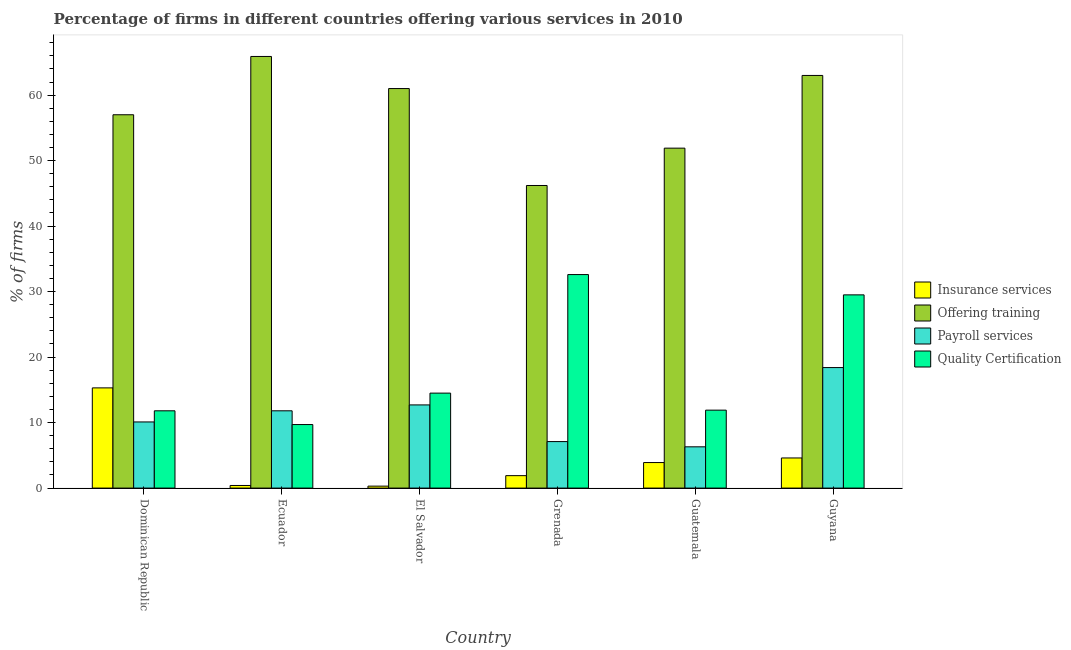How many groups of bars are there?
Provide a succinct answer. 6. How many bars are there on the 6th tick from the right?
Your answer should be compact. 4. What is the label of the 3rd group of bars from the left?
Your answer should be compact. El Salvador. In how many cases, is the number of bars for a given country not equal to the number of legend labels?
Provide a short and direct response. 0. Across all countries, what is the minimum percentage of firms offering insurance services?
Your answer should be very brief. 0.3. In which country was the percentage of firms offering training maximum?
Give a very brief answer. Ecuador. In which country was the percentage of firms offering insurance services minimum?
Your response must be concise. El Salvador. What is the total percentage of firms offering training in the graph?
Provide a succinct answer. 345. What is the difference between the percentage of firms offering payroll services in El Salvador and that in Guyana?
Offer a very short reply. -5.7. What is the difference between the percentage of firms offering insurance services in Ecuador and the percentage of firms offering training in Dominican Republic?
Provide a succinct answer. -56.6. What is the average percentage of firms offering quality certification per country?
Provide a short and direct response. 18.33. In how many countries, is the percentage of firms offering insurance services greater than 60 %?
Offer a terse response. 0. What is the ratio of the percentage of firms offering quality certification in Ecuador to that in Grenada?
Provide a succinct answer. 0.3. What is the difference between the highest and the second highest percentage of firms offering training?
Make the answer very short. 2.9. What is the difference between the highest and the lowest percentage of firms offering payroll services?
Provide a succinct answer. 12.1. In how many countries, is the percentage of firms offering training greater than the average percentage of firms offering training taken over all countries?
Make the answer very short. 3. Is the sum of the percentage of firms offering training in El Salvador and Grenada greater than the maximum percentage of firms offering insurance services across all countries?
Offer a very short reply. Yes. Is it the case that in every country, the sum of the percentage of firms offering payroll services and percentage of firms offering training is greater than the sum of percentage of firms offering insurance services and percentage of firms offering quality certification?
Provide a short and direct response. Yes. What does the 2nd bar from the left in Grenada represents?
Offer a terse response. Offering training. What does the 3rd bar from the right in Grenada represents?
Offer a very short reply. Offering training. Is it the case that in every country, the sum of the percentage of firms offering insurance services and percentage of firms offering training is greater than the percentage of firms offering payroll services?
Make the answer very short. Yes. How many bars are there?
Offer a terse response. 24. Are all the bars in the graph horizontal?
Keep it short and to the point. No. How many countries are there in the graph?
Your answer should be compact. 6. Are the values on the major ticks of Y-axis written in scientific E-notation?
Your answer should be very brief. No. Where does the legend appear in the graph?
Offer a very short reply. Center right. How many legend labels are there?
Your response must be concise. 4. How are the legend labels stacked?
Ensure brevity in your answer.  Vertical. What is the title of the graph?
Make the answer very short. Percentage of firms in different countries offering various services in 2010. What is the label or title of the Y-axis?
Offer a terse response. % of firms. What is the % of firms of Insurance services in Dominican Republic?
Give a very brief answer. 15.3. What is the % of firms in Offering training in Dominican Republic?
Make the answer very short. 57. What is the % of firms in Payroll services in Dominican Republic?
Offer a terse response. 10.1. What is the % of firms in Offering training in Ecuador?
Give a very brief answer. 65.9. What is the % of firms in Quality Certification in Ecuador?
Your answer should be compact. 9.7. What is the % of firms of Offering training in El Salvador?
Provide a succinct answer. 61. What is the % of firms of Payroll services in El Salvador?
Make the answer very short. 12.7. What is the % of firms of Quality Certification in El Salvador?
Ensure brevity in your answer.  14.5. What is the % of firms of Offering training in Grenada?
Keep it short and to the point. 46.2. What is the % of firms in Payroll services in Grenada?
Make the answer very short. 7.1. What is the % of firms of Quality Certification in Grenada?
Provide a succinct answer. 32.6. What is the % of firms of Offering training in Guatemala?
Your answer should be compact. 51.9. What is the % of firms of Quality Certification in Guatemala?
Ensure brevity in your answer.  11.9. What is the % of firms of Quality Certification in Guyana?
Offer a terse response. 29.5. Across all countries, what is the maximum % of firms of Offering training?
Provide a short and direct response. 65.9. Across all countries, what is the maximum % of firms of Quality Certification?
Your response must be concise. 32.6. Across all countries, what is the minimum % of firms in Offering training?
Offer a terse response. 46.2. What is the total % of firms of Insurance services in the graph?
Keep it short and to the point. 26.4. What is the total % of firms in Offering training in the graph?
Provide a succinct answer. 345. What is the total % of firms of Payroll services in the graph?
Offer a very short reply. 66.4. What is the total % of firms in Quality Certification in the graph?
Make the answer very short. 110. What is the difference between the % of firms of Quality Certification in Dominican Republic and that in Grenada?
Your response must be concise. -20.8. What is the difference between the % of firms of Payroll services in Dominican Republic and that in Guatemala?
Keep it short and to the point. 3.8. What is the difference between the % of firms in Quality Certification in Dominican Republic and that in Guyana?
Give a very brief answer. -17.7. What is the difference between the % of firms of Insurance services in Ecuador and that in El Salvador?
Ensure brevity in your answer.  0.1. What is the difference between the % of firms of Payroll services in Ecuador and that in El Salvador?
Offer a very short reply. -0.9. What is the difference between the % of firms in Payroll services in Ecuador and that in Grenada?
Make the answer very short. 4.7. What is the difference between the % of firms of Quality Certification in Ecuador and that in Grenada?
Offer a very short reply. -22.9. What is the difference between the % of firms of Insurance services in Ecuador and that in Guatemala?
Your answer should be compact. -3.5. What is the difference between the % of firms of Offering training in Ecuador and that in Guyana?
Give a very brief answer. 2.9. What is the difference between the % of firms of Quality Certification in Ecuador and that in Guyana?
Keep it short and to the point. -19.8. What is the difference between the % of firms in Offering training in El Salvador and that in Grenada?
Offer a terse response. 14.8. What is the difference between the % of firms in Quality Certification in El Salvador and that in Grenada?
Offer a terse response. -18.1. What is the difference between the % of firms of Payroll services in El Salvador and that in Guatemala?
Make the answer very short. 6.4. What is the difference between the % of firms of Payroll services in El Salvador and that in Guyana?
Offer a terse response. -5.7. What is the difference between the % of firms of Insurance services in Grenada and that in Guatemala?
Ensure brevity in your answer.  -2. What is the difference between the % of firms of Quality Certification in Grenada and that in Guatemala?
Ensure brevity in your answer.  20.7. What is the difference between the % of firms in Offering training in Grenada and that in Guyana?
Offer a very short reply. -16.8. What is the difference between the % of firms in Payroll services in Grenada and that in Guyana?
Provide a short and direct response. -11.3. What is the difference between the % of firms in Insurance services in Guatemala and that in Guyana?
Offer a very short reply. -0.7. What is the difference between the % of firms in Offering training in Guatemala and that in Guyana?
Offer a terse response. -11.1. What is the difference between the % of firms in Payroll services in Guatemala and that in Guyana?
Make the answer very short. -12.1. What is the difference between the % of firms in Quality Certification in Guatemala and that in Guyana?
Your answer should be compact. -17.6. What is the difference between the % of firms in Insurance services in Dominican Republic and the % of firms in Offering training in Ecuador?
Your answer should be compact. -50.6. What is the difference between the % of firms of Insurance services in Dominican Republic and the % of firms of Quality Certification in Ecuador?
Provide a succinct answer. 5.6. What is the difference between the % of firms of Offering training in Dominican Republic and the % of firms of Payroll services in Ecuador?
Give a very brief answer. 45.2. What is the difference between the % of firms in Offering training in Dominican Republic and the % of firms in Quality Certification in Ecuador?
Offer a very short reply. 47.3. What is the difference between the % of firms in Payroll services in Dominican Republic and the % of firms in Quality Certification in Ecuador?
Provide a succinct answer. 0.4. What is the difference between the % of firms in Insurance services in Dominican Republic and the % of firms in Offering training in El Salvador?
Your answer should be very brief. -45.7. What is the difference between the % of firms in Insurance services in Dominican Republic and the % of firms in Quality Certification in El Salvador?
Your response must be concise. 0.8. What is the difference between the % of firms in Offering training in Dominican Republic and the % of firms in Payroll services in El Salvador?
Your answer should be compact. 44.3. What is the difference between the % of firms of Offering training in Dominican Republic and the % of firms of Quality Certification in El Salvador?
Provide a short and direct response. 42.5. What is the difference between the % of firms in Insurance services in Dominican Republic and the % of firms in Offering training in Grenada?
Offer a very short reply. -30.9. What is the difference between the % of firms in Insurance services in Dominican Republic and the % of firms in Quality Certification in Grenada?
Your answer should be very brief. -17.3. What is the difference between the % of firms in Offering training in Dominican Republic and the % of firms in Payroll services in Grenada?
Provide a succinct answer. 49.9. What is the difference between the % of firms in Offering training in Dominican Republic and the % of firms in Quality Certification in Grenada?
Make the answer very short. 24.4. What is the difference between the % of firms of Payroll services in Dominican Republic and the % of firms of Quality Certification in Grenada?
Offer a very short reply. -22.5. What is the difference between the % of firms in Insurance services in Dominican Republic and the % of firms in Offering training in Guatemala?
Offer a very short reply. -36.6. What is the difference between the % of firms in Insurance services in Dominican Republic and the % of firms in Payroll services in Guatemala?
Keep it short and to the point. 9. What is the difference between the % of firms of Insurance services in Dominican Republic and the % of firms of Quality Certification in Guatemala?
Give a very brief answer. 3.4. What is the difference between the % of firms of Offering training in Dominican Republic and the % of firms of Payroll services in Guatemala?
Your response must be concise. 50.7. What is the difference between the % of firms of Offering training in Dominican Republic and the % of firms of Quality Certification in Guatemala?
Give a very brief answer. 45.1. What is the difference between the % of firms of Insurance services in Dominican Republic and the % of firms of Offering training in Guyana?
Your response must be concise. -47.7. What is the difference between the % of firms in Insurance services in Dominican Republic and the % of firms in Quality Certification in Guyana?
Your answer should be very brief. -14.2. What is the difference between the % of firms in Offering training in Dominican Republic and the % of firms in Payroll services in Guyana?
Provide a short and direct response. 38.6. What is the difference between the % of firms of Payroll services in Dominican Republic and the % of firms of Quality Certification in Guyana?
Your answer should be very brief. -19.4. What is the difference between the % of firms of Insurance services in Ecuador and the % of firms of Offering training in El Salvador?
Your answer should be compact. -60.6. What is the difference between the % of firms in Insurance services in Ecuador and the % of firms in Payroll services in El Salvador?
Offer a terse response. -12.3. What is the difference between the % of firms in Insurance services in Ecuador and the % of firms in Quality Certification in El Salvador?
Offer a very short reply. -14.1. What is the difference between the % of firms of Offering training in Ecuador and the % of firms of Payroll services in El Salvador?
Offer a terse response. 53.2. What is the difference between the % of firms in Offering training in Ecuador and the % of firms in Quality Certification in El Salvador?
Provide a succinct answer. 51.4. What is the difference between the % of firms in Insurance services in Ecuador and the % of firms in Offering training in Grenada?
Give a very brief answer. -45.8. What is the difference between the % of firms of Insurance services in Ecuador and the % of firms of Quality Certification in Grenada?
Your answer should be compact. -32.2. What is the difference between the % of firms in Offering training in Ecuador and the % of firms in Payroll services in Grenada?
Provide a succinct answer. 58.8. What is the difference between the % of firms in Offering training in Ecuador and the % of firms in Quality Certification in Grenada?
Give a very brief answer. 33.3. What is the difference between the % of firms in Payroll services in Ecuador and the % of firms in Quality Certification in Grenada?
Provide a succinct answer. -20.8. What is the difference between the % of firms in Insurance services in Ecuador and the % of firms in Offering training in Guatemala?
Make the answer very short. -51.5. What is the difference between the % of firms of Offering training in Ecuador and the % of firms of Payroll services in Guatemala?
Ensure brevity in your answer.  59.6. What is the difference between the % of firms of Insurance services in Ecuador and the % of firms of Offering training in Guyana?
Your answer should be compact. -62.6. What is the difference between the % of firms of Insurance services in Ecuador and the % of firms of Payroll services in Guyana?
Your answer should be very brief. -18. What is the difference between the % of firms of Insurance services in Ecuador and the % of firms of Quality Certification in Guyana?
Ensure brevity in your answer.  -29.1. What is the difference between the % of firms of Offering training in Ecuador and the % of firms of Payroll services in Guyana?
Give a very brief answer. 47.5. What is the difference between the % of firms in Offering training in Ecuador and the % of firms in Quality Certification in Guyana?
Ensure brevity in your answer.  36.4. What is the difference between the % of firms of Payroll services in Ecuador and the % of firms of Quality Certification in Guyana?
Give a very brief answer. -17.7. What is the difference between the % of firms of Insurance services in El Salvador and the % of firms of Offering training in Grenada?
Your answer should be very brief. -45.9. What is the difference between the % of firms of Insurance services in El Salvador and the % of firms of Payroll services in Grenada?
Provide a succinct answer. -6.8. What is the difference between the % of firms of Insurance services in El Salvador and the % of firms of Quality Certification in Grenada?
Keep it short and to the point. -32.3. What is the difference between the % of firms of Offering training in El Salvador and the % of firms of Payroll services in Grenada?
Your answer should be very brief. 53.9. What is the difference between the % of firms of Offering training in El Salvador and the % of firms of Quality Certification in Grenada?
Offer a very short reply. 28.4. What is the difference between the % of firms in Payroll services in El Salvador and the % of firms in Quality Certification in Grenada?
Provide a short and direct response. -19.9. What is the difference between the % of firms of Insurance services in El Salvador and the % of firms of Offering training in Guatemala?
Your answer should be compact. -51.6. What is the difference between the % of firms in Insurance services in El Salvador and the % of firms in Payroll services in Guatemala?
Provide a succinct answer. -6. What is the difference between the % of firms in Insurance services in El Salvador and the % of firms in Quality Certification in Guatemala?
Give a very brief answer. -11.6. What is the difference between the % of firms of Offering training in El Salvador and the % of firms of Payroll services in Guatemala?
Your answer should be very brief. 54.7. What is the difference between the % of firms of Offering training in El Salvador and the % of firms of Quality Certification in Guatemala?
Your answer should be very brief. 49.1. What is the difference between the % of firms in Payroll services in El Salvador and the % of firms in Quality Certification in Guatemala?
Provide a succinct answer. 0.8. What is the difference between the % of firms of Insurance services in El Salvador and the % of firms of Offering training in Guyana?
Provide a succinct answer. -62.7. What is the difference between the % of firms of Insurance services in El Salvador and the % of firms of Payroll services in Guyana?
Your response must be concise. -18.1. What is the difference between the % of firms of Insurance services in El Salvador and the % of firms of Quality Certification in Guyana?
Your answer should be compact. -29.2. What is the difference between the % of firms of Offering training in El Salvador and the % of firms of Payroll services in Guyana?
Offer a very short reply. 42.6. What is the difference between the % of firms of Offering training in El Salvador and the % of firms of Quality Certification in Guyana?
Provide a short and direct response. 31.5. What is the difference between the % of firms of Payroll services in El Salvador and the % of firms of Quality Certification in Guyana?
Make the answer very short. -16.8. What is the difference between the % of firms in Insurance services in Grenada and the % of firms in Quality Certification in Guatemala?
Provide a succinct answer. -10. What is the difference between the % of firms of Offering training in Grenada and the % of firms of Payroll services in Guatemala?
Ensure brevity in your answer.  39.9. What is the difference between the % of firms of Offering training in Grenada and the % of firms of Quality Certification in Guatemala?
Offer a very short reply. 34.3. What is the difference between the % of firms in Payroll services in Grenada and the % of firms in Quality Certification in Guatemala?
Offer a very short reply. -4.8. What is the difference between the % of firms of Insurance services in Grenada and the % of firms of Offering training in Guyana?
Offer a very short reply. -61.1. What is the difference between the % of firms of Insurance services in Grenada and the % of firms of Payroll services in Guyana?
Provide a succinct answer. -16.5. What is the difference between the % of firms in Insurance services in Grenada and the % of firms in Quality Certification in Guyana?
Offer a terse response. -27.6. What is the difference between the % of firms of Offering training in Grenada and the % of firms of Payroll services in Guyana?
Offer a terse response. 27.8. What is the difference between the % of firms of Payroll services in Grenada and the % of firms of Quality Certification in Guyana?
Keep it short and to the point. -22.4. What is the difference between the % of firms in Insurance services in Guatemala and the % of firms in Offering training in Guyana?
Make the answer very short. -59.1. What is the difference between the % of firms in Insurance services in Guatemala and the % of firms in Payroll services in Guyana?
Keep it short and to the point. -14.5. What is the difference between the % of firms in Insurance services in Guatemala and the % of firms in Quality Certification in Guyana?
Your answer should be compact. -25.6. What is the difference between the % of firms in Offering training in Guatemala and the % of firms in Payroll services in Guyana?
Your answer should be very brief. 33.5. What is the difference between the % of firms of Offering training in Guatemala and the % of firms of Quality Certification in Guyana?
Keep it short and to the point. 22.4. What is the difference between the % of firms of Payroll services in Guatemala and the % of firms of Quality Certification in Guyana?
Offer a terse response. -23.2. What is the average % of firms of Offering training per country?
Make the answer very short. 57.5. What is the average % of firms of Payroll services per country?
Make the answer very short. 11.07. What is the average % of firms in Quality Certification per country?
Your answer should be compact. 18.33. What is the difference between the % of firms in Insurance services and % of firms in Offering training in Dominican Republic?
Offer a very short reply. -41.7. What is the difference between the % of firms in Insurance services and % of firms in Quality Certification in Dominican Republic?
Your response must be concise. 3.5. What is the difference between the % of firms of Offering training and % of firms of Payroll services in Dominican Republic?
Give a very brief answer. 46.9. What is the difference between the % of firms of Offering training and % of firms of Quality Certification in Dominican Republic?
Provide a short and direct response. 45.2. What is the difference between the % of firms of Insurance services and % of firms of Offering training in Ecuador?
Provide a succinct answer. -65.5. What is the difference between the % of firms of Insurance services and % of firms of Quality Certification in Ecuador?
Provide a succinct answer. -9.3. What is the difference between the % of firms of Offering training and % of firms of Payroll services in Ecuador?
Make the answer very short. 54.1. What is the difference between the % of firms in Offering training and % of firms in Quality Certification in Ecuador?
Provide a short and direct response. 56.2. What is the difference between the % of firms of Payroll services and % of firms of Quality Certification in Ecuador?
Provide a succinct answer. 2.1. What is the difference between the % of firms of Insurance services and % of firms of Offering training in El Salvador?
Your answer should be very brief. -60.7. What is the difference between the % of firms of Insurance services and % of firms of Payroll services in El Salvador?
Your answer should be compact. -12.4. What is the difference between the % of firms of Insurance services and % of firms of Quality Certification in El Salvador?
Give a very brief answer. -14.2. What is the difference between the % of firms of Offering training and % of firms of Payroll services in El Salvador?
Provide a succinct answer. 48.3. What is the difference between the % of firms of Offering training and % of firms of Quality Certification in El Salvador?
Ensure brevity in your answer.  46.5. What is the difference between the % of firms in Insurance services and % of firms in Offering training in Grenada?
Ensure brevity in your answer.  -44.3. What is the difference between the % of firms in Insurance services and % of firms in Quality Certification in Grenada?
Your response must be concise. -30.7. What is the difference between the % of firms of Offering training and % of firms of Payroll services in Grenada?
Give a very brief answer. 39.1. What is the difference between the % of firms in Offering training and % of firms in Quality Certification in Grenada?
Your response must be concise. 13.6. What is the difference between the % of firms in Payroll services and % of firms in Quality Certification in Grenada?
Your answer should be very brief. -25.5. What is the difference between the % of firms in Insurance services and % of firms in Offering training in Guatemala?
Make the answer very short. -48. What is the difference between the % of firms in Insurance services and % of firms in Payroll services in Guatemala?
Your answer should be very brief. -2.4. What is the difference between the % of firms of Insurance services and % of firms of Quality Certification in Guatemala?
Your response must be concise. -8. What is the difference between the % of firms of Offering training and % of firms of Payroll services in Guatemala?
Ensure brevity in your answer.  45.6. What is the difference between the % of firms of Offering training and % of firms of Quality Certification in Guatemala?
Your answer should be compact. 40. What is the difference between the % of firms of Payroll services and % of firms of Quality Certification in Guatemala?
Ensure brevity in your answer.  -5.6. What is the difference between the % of firms in Insurance services and % of firms in Offering training in Guyana?
Give a very brief answer. -58.4. What is the difference between the % of firms in Insurance services and % of firms in Payroll services in Guyana?
Offer a very short reply. -13.8. What is the difference between the % of firms of Insurance services and % of firms of Quality Certification in Guyana?
Your answer should be very brief. -24.9. What is the difference between the % of firms in Offering training and % of firms in Payroll services in Guyana?
Make the answer very short. 44.6. What is the difference between the % of firms of Offering training and % of firms of Quality Certification in Guyana?
Your response must be concise. 33.5. What is the ratio of the % of firms in Insurance services in Dominican Republic to that in Ecuador?
Offer a very short reply. 38.25. What is the ratio of the % of firms in Offering training in Dominican Republic to that in Ecuador?
Provide a short and direct response. 0.86. What is the ratio of the % of firms of Payroll services in Dominican Republic to that in Ecuador?
Offer a very short reply. 0.86. What is the ratio of the % of firms of Quality Certification in Dominican Republic to that in Ecuador?
Keep it short and to the point. 1.22. What is the ratio of the % of firms of Offering training in Dominican Republic to that in El Salvador?
Offer a very short reply. 0.93. What is the ratio of the % of firms of Payroll services in Dominican Republic to that in El Salvador?
Offer a terse response. 0.8. What is the ratio of the % of firms in Quality Certification in Dominican Republic to that in El Salvador?
Provide a short and direct response. 0.81. What is the ratio of the % of firms in Insurance services in Dominican Republic to that in Grenada?
Ensure brevity in your answer.  8.05. What is the ratio of the % of firms in Offering training in Dominican Republic to that in Grenada?
Provide a succinct answer. 1.23. What is the ratio of the % of firms in Payroll services in Dominican Republic to that in Grenada?
Ensure brevity in your answer.  1.42. What is the ratio of the % of firms in Quality Certification in Dominican Republic to that in Grenada?
Provide a short and direct response. 0.36. What is the ratio of the % of firms of Insurance services in Dominican Republic to that in Guatemala?
Ensure brevity in your answer.  3.92. What is the ratio of the % of firms of Offering training in Dominican Republic to that in Guatemala?
Your answer should be compact. 1.1. What is the ratio of the % of firms of Payroll services in Dominican Republic to that in Guatemala?
Offer a very short reply. 1.6. What is the ratio of the % of firms of Quality Certification in Dominican Republic to that in Guatemala?
Provide a succinct answer. 0.99. What is the ratio of the % of firms of Insurance services in Dominican Republic to that in Guyana?
Offer a very short reply. 3.33. What is the ratio of the % of firms in Offering training in Dominican Republic to that in Guyana?
Your response must be concise. 0.9. What is the ratio of the % of firms in Payroll services in Dominican Republic to that in Guyana?
Ensure brevity in your answer.  0.55. What is the ratio of the % of firms in Quality Certification in Dominican Republic to that in Guyana?
Keep it short and to the point. 0.4. What is the ratio of the % of firms of Offering training in Ecuador to that in El Salvador?
Keep it short and to the point. 1.08. What is the ratio of the % of firms in Payroll services in Ecuador to that in El Salvador?
Keep it short and to the point. 0.93. What is the ratio of the % of firms of Quality Certification in Ecuador to that in El Salvador?
Your answer should be compact. 0.67. What is the ratio of the % of firms in Insurance services in Ecuador to that in Grenada?
Your answer should be compact. 0.21. What is the ratio of the % of firms of Offering training in Ecuador to that in Grenada?
Provide a succinct answer. 1.43. What is the ratio of the % of firms in Payroll services in Ecuador to that in Grenada?
Offer a terse response. 1.66. What is the ratio of the % of firms in Quality Certification in Ecuador to that in Grenada?
Give a very brief answer. 0.3. What is the ratio of the % of firms of Insurance services in Ecuador to that in Guatemala?
Keep it short and to the point. 0.1. What is the ratio of the % of firms in Offering training in Ecuador to that in Guatemala?
Provide a succinct answer. 1.27. What is the ratio of the % of firms in Payroll services in Ecuador to that in Guatemala?
Offer a very short reply. 1.87. What is the ratio of the % of firms in Quality Certification in Ecuador to that in Guatemala?
Offer a very short reply. 0.82. What is the ratio of the % of firms of Insurance services in Ecuador to that in Guyana?
Keep it short and to the point. 0.09. What is the ratio of the % of firms of Offering training in Ecuador to that in Guyana?
Provide a short and direct response. 1.05. What is the ratio of the % of firms of Payroll services in Ecuador to that in Guyana?
Ensure brevity in your answer.  0.64. What is the ratio of the % of firms in Quality Certification in Ecuador to that in Guyana?
Offer a terse response. 0.33. What is the ratio of the % of firms in Insurance services in El Salvador to that in Grenada?
Ensure brevity in your answer.  0.16. What is the ratio of the % of firms of Offering training in El Salvador to that in Grenada?
Keep it short and to the point. 1.32. What is the ratio of the % of firms in Payroll services in El Salvador to that in Grenada?
Keep it short and to the point. 1.79. What is the ratio of the % of firms of Quality Certification in El Salvador to that in Grenada?
Your answer should be very brief. 0.44. What is the ratio of the % of firms of Insurance services in El Salvador to that in Guatemala?
Offer a terse response. 0.08. What is the ratio of the % of firms of Offering training in El Salvador to that in Guatemala?
Give a very brief answer. 1.18. What is the ratio of the % of firms in Payroll services in El Salvador to that in Guatemala?
Make the answer very short. 2.02. What is the ratio of the % of firms of Quality Certification in El Salvador to that in Guatemala?
Keep it short and to the point. 1.22. What is the ratio of the % of firms in Insurance services in El Salvador to that in Guyana?
Make the answer very short. 0.07. What is the ratio of the % of firms in Offering training in El Salvador to that in Guyana?
Offer a terse response. 0.97. What is the ratio of the % of firms of Payroll services in El Salvador to that in Guyana?
Provide a short and direct response. 0.69. What is the ratio of the % of firms of Quality Certification in El Salvador to that in Guyana?
Make the answer very short. 0.49. What is the ratio of the % of firms in Insurance services in Grenada to that in Guatemala?
Give a very brief answer. 0.49. What is the ratio of the % of firms of Offering training in Grenada to that in Guatemala?
Keep it short and to the point. 0.89. What is the ratio of the % of firms of Payroll services in Grenada to that in Guatemala?
Provide a succinct answer. 1.13. What is the ratio of the % of firms of Quality Certification in Grenada to that in Guatemala?
Ensure brevity in your answer.  2.74. What is the ratio of the % of firms of Insurance services in Grenada to that in Guyana?
Your answer should be compact. 0.41. What is the ratio of the % of firms of Offering training in Grenada to that in Guyana?
Ensure brevity in your answer.  0.73. What is the ratio of the % of firms in Payroll services in Grenada to that in Guyana?
Your response must be concise. 0.39. What is the ratio of the % of firms of Quality Certification in Grenada to that in Guyana?
Your answer should be compact. 1.11. What is the ratio of the % of firms in Insurance services in Guatemala to that in Guyana?
Make the answer very short. 0.85. What is the ratio of the % of firms of Offering training in Guatemala to that in Guyana?
Your answer should be very brief. 0.82. What is the ratio of the % of firms of Payroll services in Guatemala to that in Guyana?
Offer a terse response. 0.34. What is the ratio of the % of firms in Quality Certification in Guatemala to that in Guyana?
Ensure brevity in your answer.  0.4. What is the difference between the highest and the second highest % of firms of Insurance services?
Give a very brief answer. 10.7. What is the difference between the highest and the lowest % of firms in Insurance services?
Give a very brief answer. 15. What is the difference between the highest and the lowest % of firms in Offering training?
Keep it short and to the point. 19.7. What is the difference between the highest and the lowest % of firms of Payroll services?
Your answer should be compact. 12.1. What is the difference between the highest and the lowest % of firms of Quality Certification?
Offer a terse response. 22.9. 